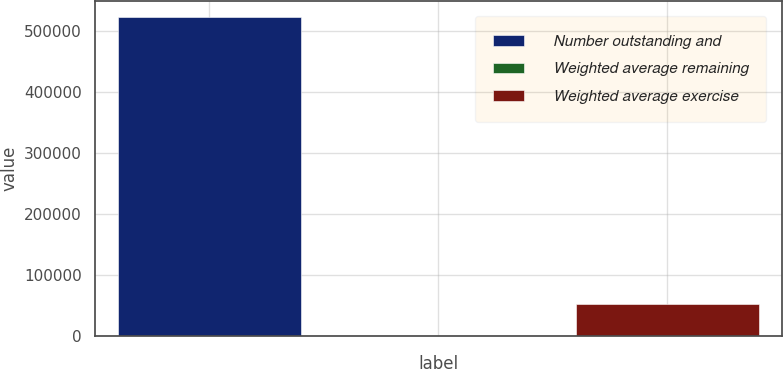<chart> <loc_0><loc_0><loc_500><loc_500><bar_chart><fcel>Number outstanding and<fcel>Weighted average remaining<fcel>Weighted average exercise<nl><fcel>523083<fcel>1.5<fcel>52309.7<nl></chart> 